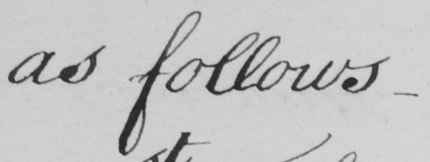What does this handwritten line say? as follows_ 